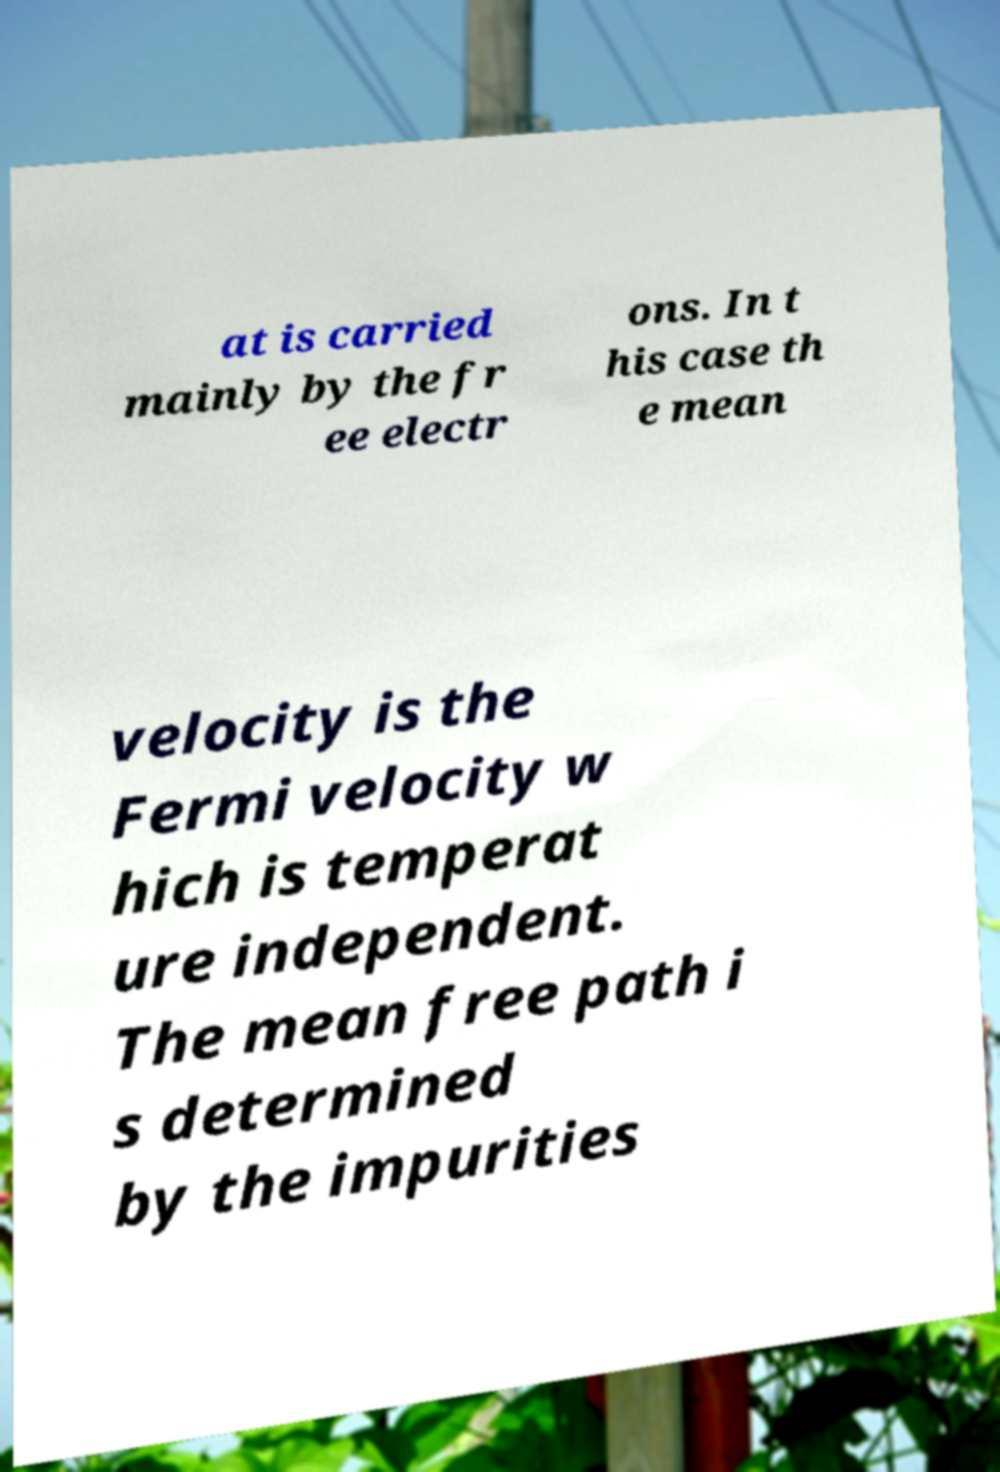There's text embedded in this image that I need extracted. Can you transcribe it verbatim? at is carried mainly by the fr ee electr ons. In t his case th e mean velocity is the Fermi velocity w hich is temperat ure independent. The mean free path i s determined by the impurities 